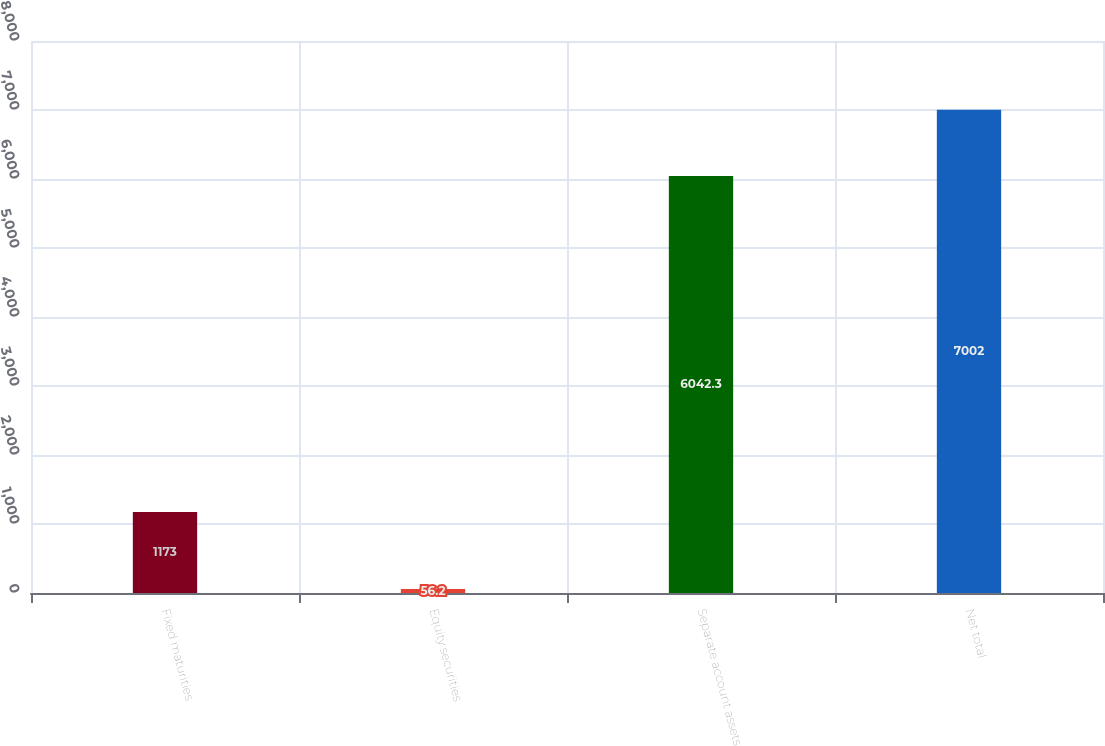<chart> <loc_0><loc_0><loc_500><loc_500><bar_chart><fcel>Fixed maturities<fcel>Equity securities<fcel>Separate account assets<fcel>Net total<nl><fcel>1173<fcel>56.2<fcel>6042.3<fcel>7002<nl></chart> 